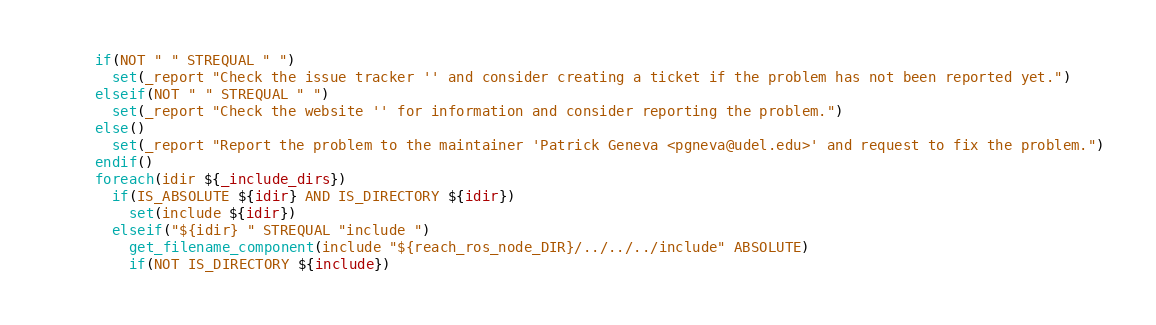Convert code to text. <code><loc_0><loc_0><loc_500><loc_500><_CMake_>  if(NOT " " STREQUAL " ")
    set(_report "Check the issue tracker '' and consider creating a ticket if the problem has not been reported yet.")
  elseif(NOT " " STREQUAL " ")
    set(_report "Check the website '' for information and consider reporting the problem.")
  else()
    set(_report "Report the problem to the maintainer 'Patrick Geneva <pgneva@udel.edu>' and request to fix the problem.")
  endif()
  foreach(idir ${_include_dirs})
    if(IS_ABSOLUTE ${idir} AND IS_DIRECTORY ${idir})
      set(include ${idir})
    elseif("${idir} " STREQUAL "include ")
      get_filename_component(include "${reach_ros_node_DIR}/../../../include" ABSOLUTE)
      if(NOT IS_DIRECTORY ${include})</code> 